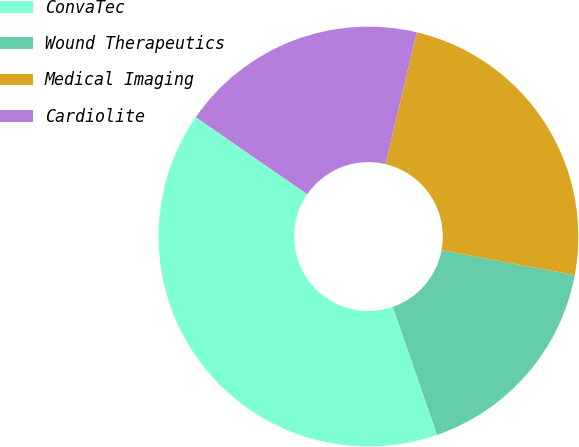<chart> <loc_0><loc_0><loc_500><loc_500><pie_chart><fcel>ConvaTec<fcel>Wound Therapeutics<fcel>Medical Imaging<fcel>Cardiolite<nl><fcel>39.94%<fcel>16.75%<fcel>24.24%<fcel>19.07%<nl></chart> 